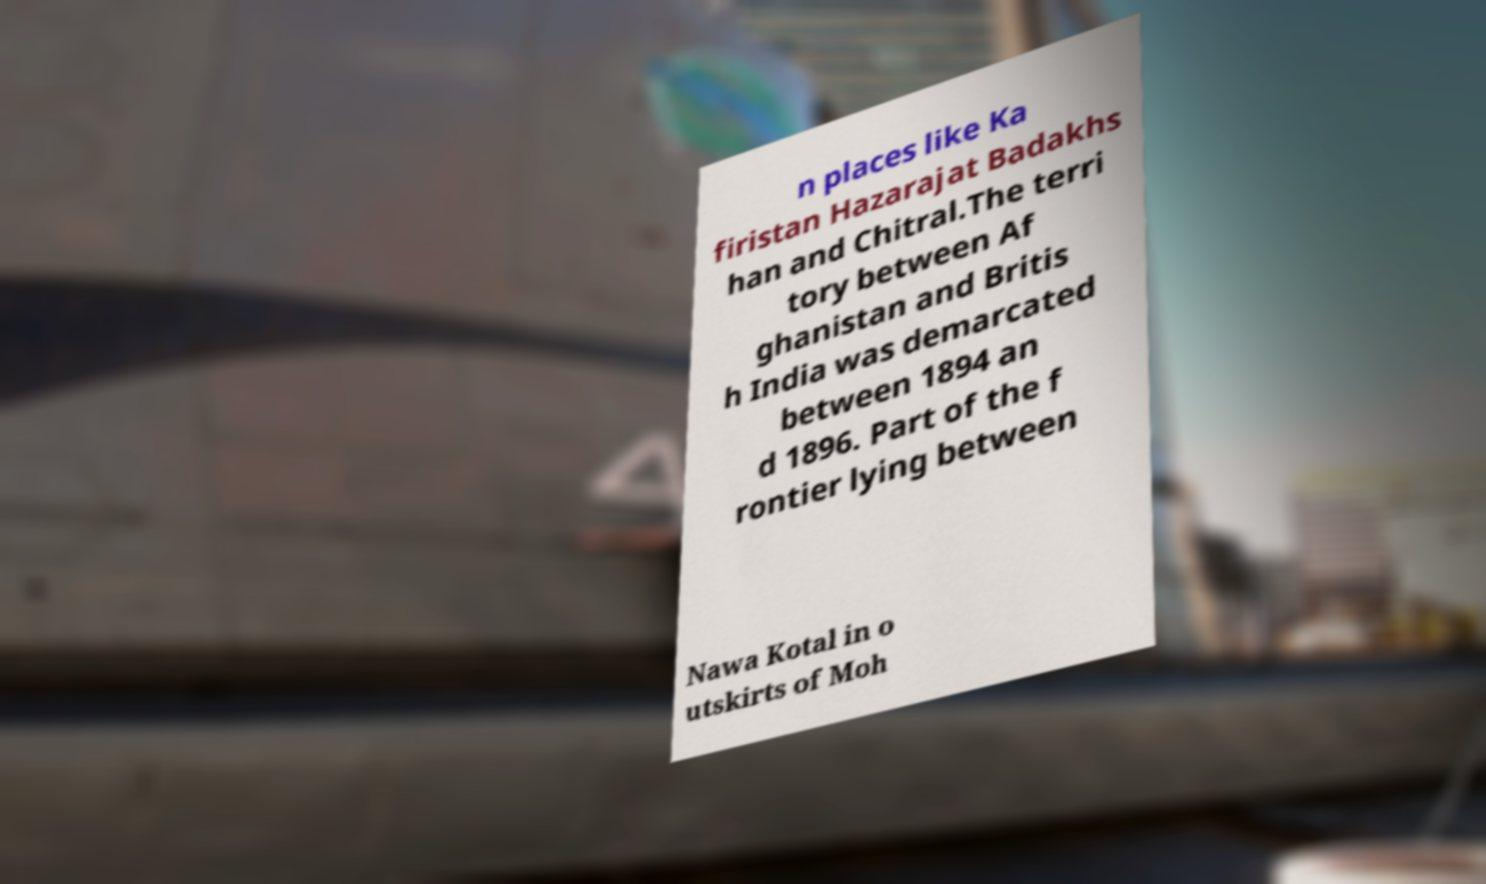What messages or text are displayed in this image? I need them in a readable, typed format. n places like Ka firistan Hazarajat Badakhs han and Chitral.The terri tory between Af ghanistan and Britis h India was demarcated between 1894 an d 1896. Part of the f rontier lying between Nawa Kotal in o utskirts of Moh 